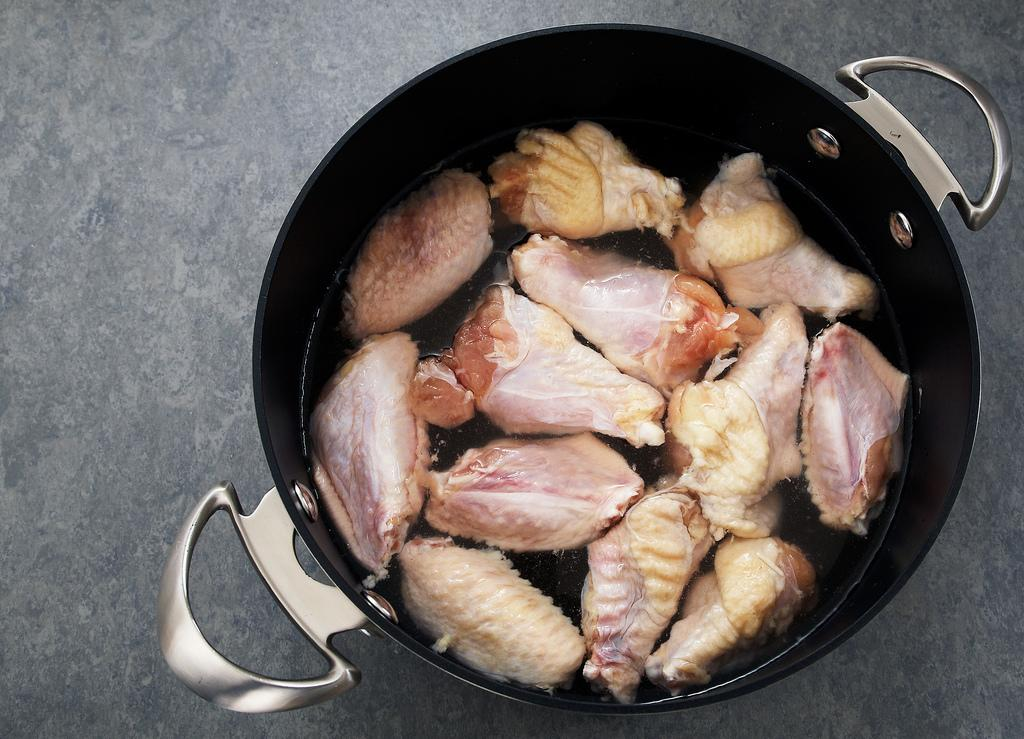What type of container is visible in the image? There is a cooking pot with handles in the image. What is inside the cooking pot? The cooking pot contains food and water. Where is the cooking pot located in the image? The cooking pot is placed on a surface. How many pencils can be seen in the image? There are no pencils present in the image. What type of voyage is depicted in the image? There is no voyage depicted in the image; it features a cooking pot with food and water. 